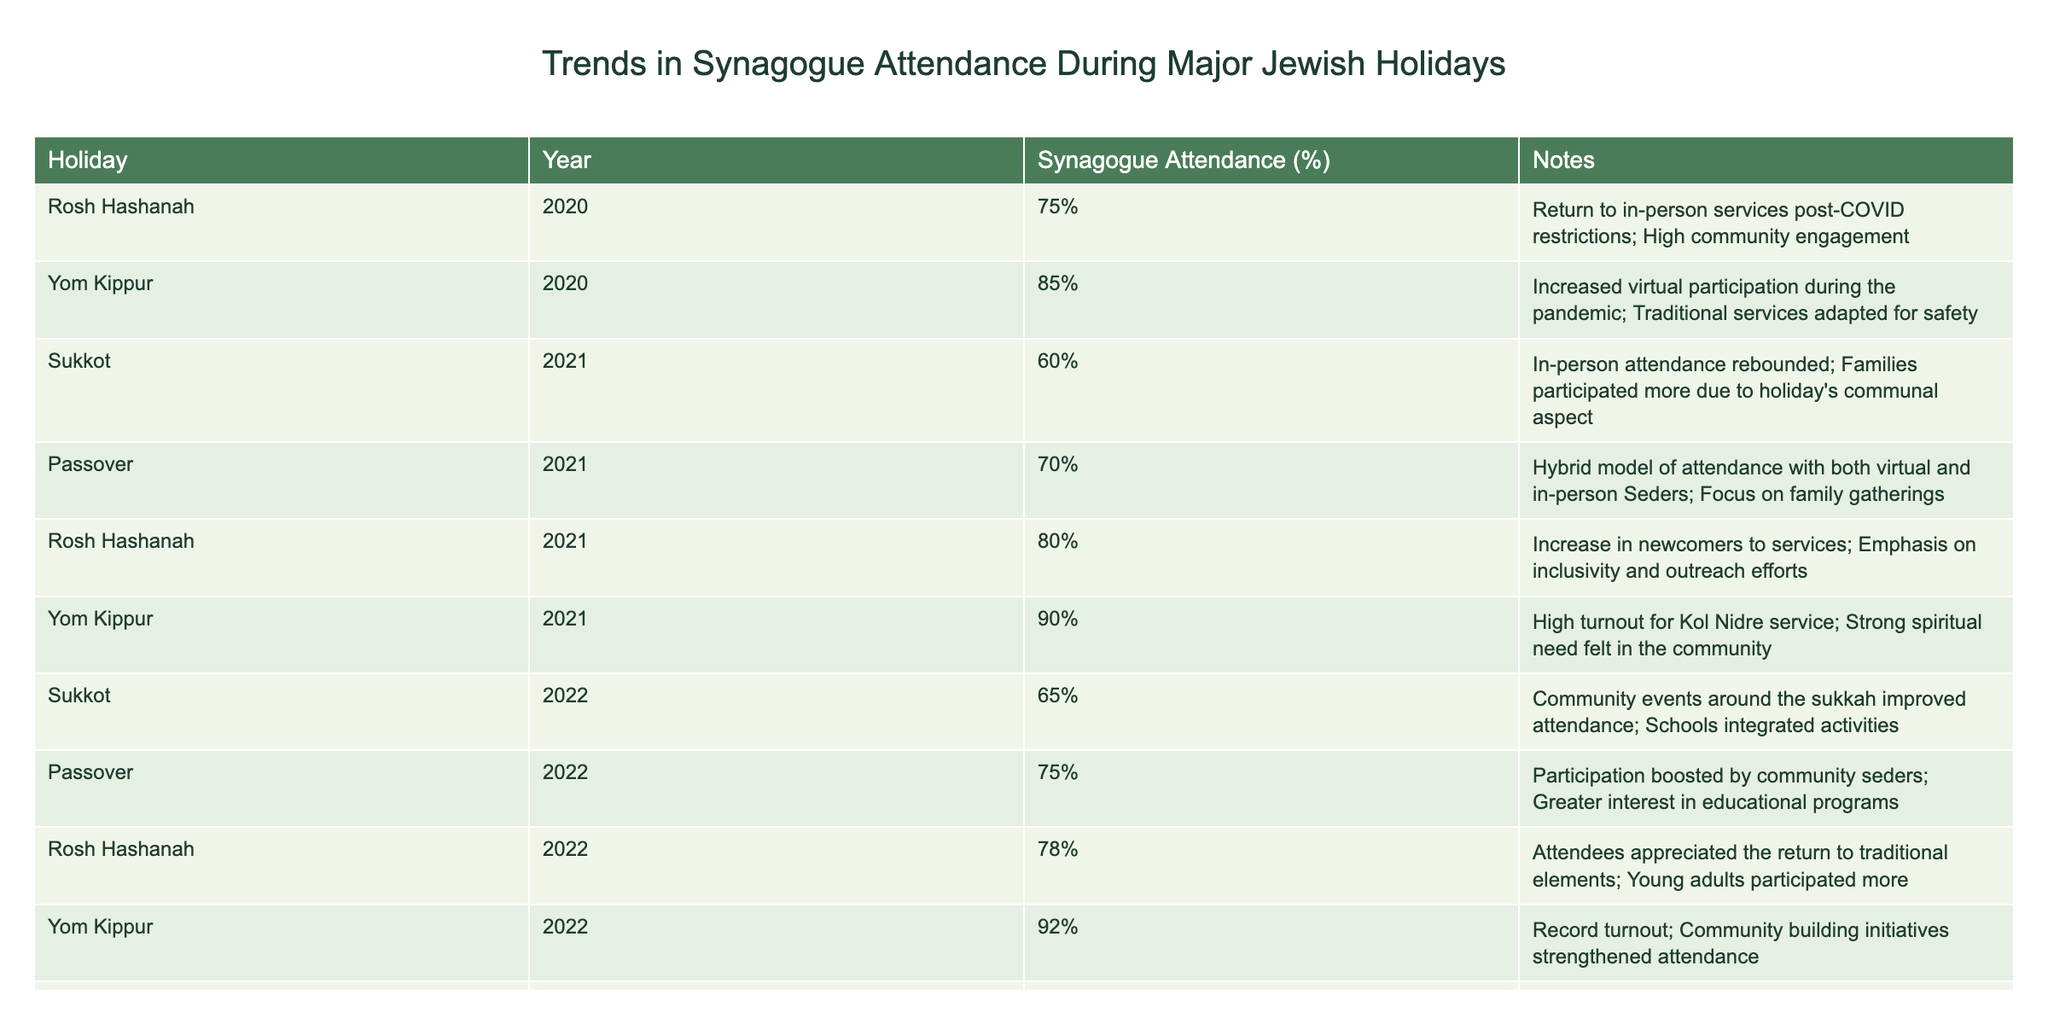What was the synagogue attendance percentage during Yom Kippur in 2022? The table shows that for Yom Kippur in 2022, the synagogue attendance percentage is listed as 92%.
Answer: 92% Which holiday had the highest attendance in 2021? In 2021, Yom Kippur had the highest attendance at 90%, compared to Rosh Hashanah at 80%, Sukkot at 60%, and Passover at 70%.
Answer: Yom Kippur What is the average synagogue attendance percentage for Rosh Hashanah across all years provided? The Rosh Hashanah attendance percentages are 75% (2020), 80% (2021), and 78% (2022). Summing them gives 233%. Dividing by 3 years results in an average of 233% / 3 = 77.67%. Rounded, this is approximately 78%.
Answer: 78% Did attendance for Sukkot in 2023 exceed attendance for Sukkot in 2022? The table lists Sukkot attendance as 70% in 2023 and 65% in 2022. Since 70% is greater than 65%, the answer is yes.
Answer: Yes What was the percentage increase in attendance for Yom Kippur from 2020 to 2021? For Yom Kippur in 2020, the attendance was 85%, and in 2021 it was 90%. The difference is 90% - 85% = 5%. To find the percentage increase: (5% / 85%) * 100 = 5.88%.
Answer: 5.88% Compare the attendance percentage of Passover between 2021 and 2022. Passover attendance was 70% in 2021 and 75% in 2022. Since 75% is greater than 70%, attendance increased.
Answer: Increased Which year had the lowest synagogue attendance for Sukkot, and what was the percentage? Reviewing the Sukkot attendance data, we see 60% in 2021, 65% in 2022, and 70% in 2023. The lowest percentage is 60% in 2021.
Answer: 2021, 60% Was there a trend of increasing attendance from 2020 to 2023 for any holiday? Analyzing the data from 2020 to 2023, attendance for Yom Kippur increased from 85% (2020) to 90% (2021) to 92% (2022). This shows an upward trend.
Answer: Yes What reason is noted for the increase in attendance for Rosh Hashanah in 2021? The table states that there was an increase in newcomers to services and a focus on inclusivity and outreach efforts, contributing to higher attendance in 2021.
Answer: Increase in newcomers and outreach efforts 